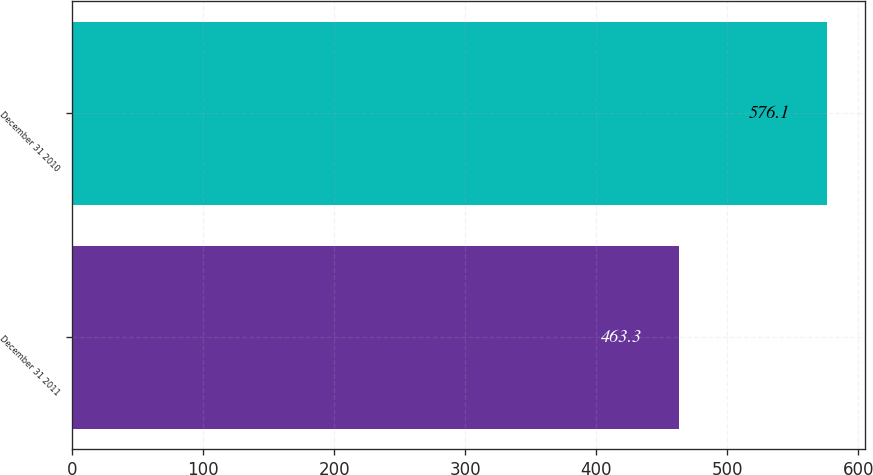<chart> <loc_0><loc_0><loc_500><loc_500><bar_chart><fcel>December 31 2011<fcel>December 31 2010<nl><fcel>463.3<fcel>576.1<nl></chart> 